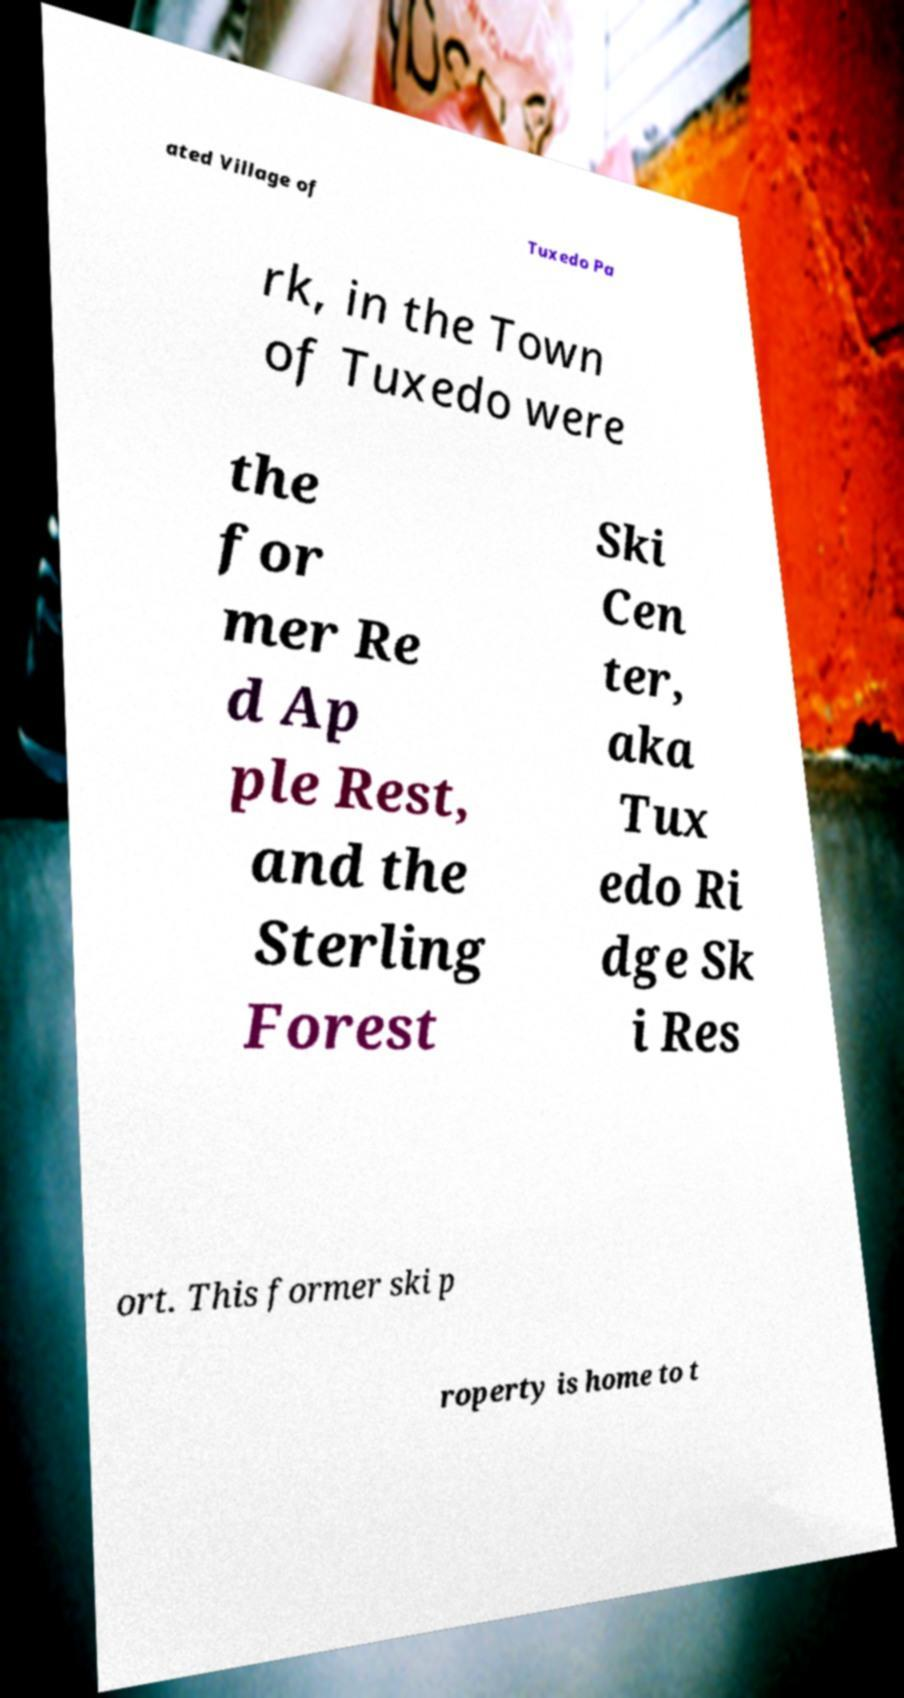For documentation purposes, I need the text within this image transcribed. Could you provide that? ated Village of Tuxedo Pa rk, in the Town of Tuxedo were the for mer Re d Ap ple Rest, and the Sterling Forest Ski Cen ter, aka Tux edo Ri dge Sk i Res ort. This former ski p roperty is home to t 